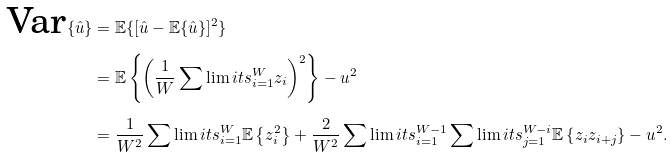Convert formula to latex. <formula><loc_0><loc_0><loc_500><loc_500>\text {Var} \{ \hat { u } \} & = \mathbb { E } \{ [ \hat { u } - \mathbb { E } \{ \hat { u } \} ] ^ { 2 } \} \\ & = \mathbb { E } \left \{ \left ( \frac { 1 } { W } \sum \lim i t s _ { i = 1 } ^ { W } z _ { i } \right ) ^ { 2 } \right \} - u ^ { 2 } \\ & = \frac { 1 } { W ^ { 2 } } \sum \lim i t s _ { i = 1 } ^ { W } \mathbb { E } \left \{ z _ { i } ^ { 2 } \right \} + \frac { 2 } { W ^ { 2 } } \sum \lim i t s _ { i = 1 } ^ { W - 1 } \sum \lim i t s _ { j = 1 } ^ { W - i } \mathbb { E } \left \{ z _ { i } z _ { i + j } \right \} - u ^ { 2 } .</formula> 